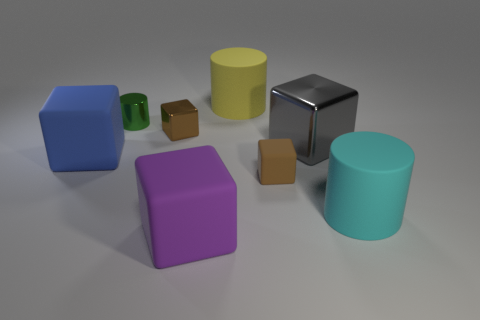Subtract all brown cubes. How many cubes are left? 3 Subtract all blue cylinders. How many brown blocks are left? 2 Add 1 big yellow matte objects. How many objects exist? 9 Subtract 1 cylinders. How many cylinders are left? 2 Subtract all brown cubes. How many cubes are left? 3 Subtract all cubes. How many objects are left? 3 Subtract all green blocks. Subtract all blue spheres. How many blocks are left? 5 Add 4 blocks. How many blocks exist? 9 Subtract 2 brown cubes. How many objects are left? 6 Subtract all big cylinders. Subtract all yellow rubber objects. How many objects are left? 5 